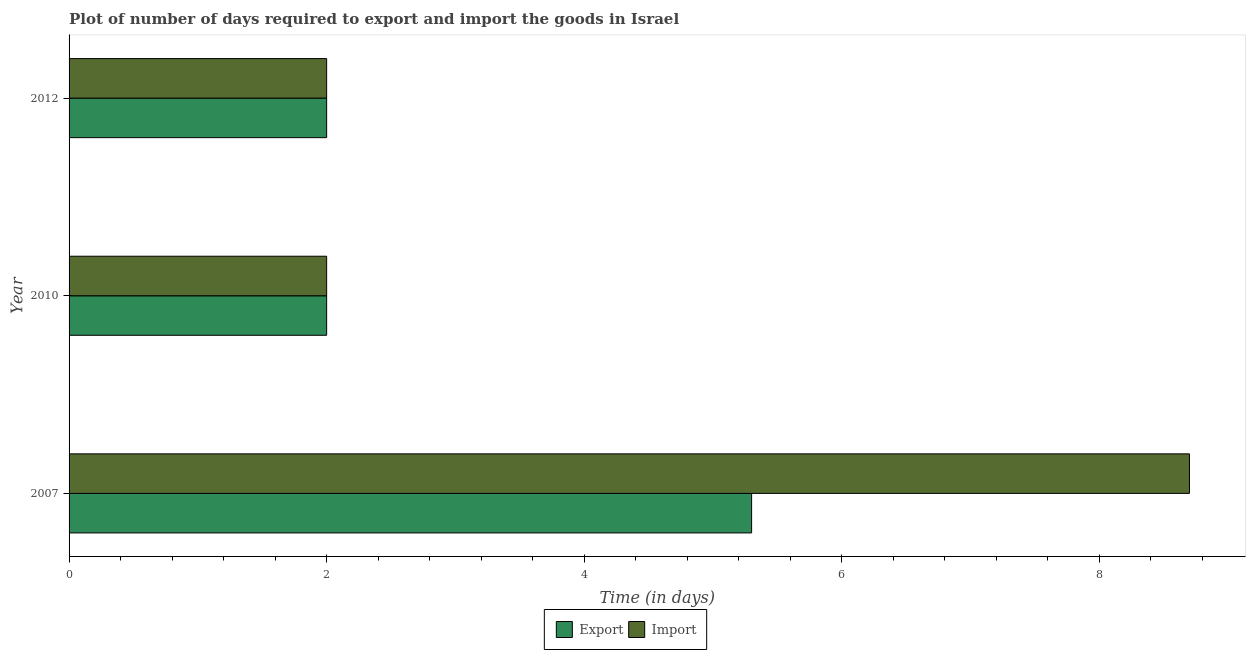How many groups of bars are there?
Ensure brevity in your answer.  3. Are the number of bars on each tick of the Y-axis equal?
Keep it short and to the point. Yes. How many bars are there on the 3rd tick from the bottom?
Keep it short and to the point. 2. What is the label of the 1st group of bars from the top?
Your response must be concise. 2012. What is the time required to import in 2007?
Keep it short and to the point. 8.7. Across all years, what is the maximum time required to import?
Make the answer very short. 8.7. In which year was the time required to import maximum?
Your response must be concise. 2007. In which year was the time required to export minimum?
Make the answer very short. 2010. What is the average time required to export per year?
Your answer should be compact. 3.1. In the year 2012, what is the difference between the time required to export and time required to import?
Your response must be concise. 0. In how many years, is the time required to export greater than 1.2000000000000002 days?
Your answer should be very brief. 3. Is the time required to export in 2007 less than that in 2012?
Offer a terse response. No. Is the difference between the time required to export in 2007 and 2010 greater than the difference between the time required to import in 2007 and 2010?
Your answer should be very brief. No. What is the difference between the highest and the second highest time required to import?
Offer a very short reply. 6.7. What does the 1st bar from the top in 2010 represents?
Your answer should be compact. Import. What does the 2nd bar from the bottom in 2012 represents?
Give a very brief answer. Import. How many years are there in the graph?
Your response must be concise. 3. What is the difference between two consecutive major ticks on the X-axis?
Your response must be concise. 2. Does the graph contain any zero values?
Keep it short and to the point. No. Does the graph contain grids?
Provide a short and direct response. No. Where does the legend appear in the graph?
Offer a terse response. Bottom center. How are the legend labels stacked?
Offer a very short reply. Horizontal. What is the title of the graph?
Keep it short and to the point. Plot of number of days required to export and import the goods in Israel. Does "Male labor force" appear as one of the legend labels in the graph?
Ensure brevity in your answer.  No. What is the label or title of the X-axis?
Your response must be concise. Time (in days). What is the label or title of the Y-axis?
Offer a very short reply. Year. What is the Time (in days) in Export in 2010?
Your response must be concise. 2. What is the Time (in days) of Import in 2010?
Offer a very short reply. 2. What is the Time (in days) of Export in 2012?
Offer a terse response. 2. Across all years, what is the maximum Time (in days) in Import?
Your answer should be very brief. 8.7. Across all years, what is the minimum Time (in days) in Import?
Your response must be concise. 2. What is the total Time (in days) in Export in the graph?
Your answer should be compact. 9.3. What is the total Time (in days) in Import in the graph?
Keep it short and to the point. 12.7. What is the difference between the Time (in days) in Export in 2007 and that in 2010?
Keep it short and to the point. 3.3. What is the difference between the Time (in days) in Import in 2007 and that in 2010?
Your response must be concise. 6.7. What is the difference between the Time (in days) of Export in 2007 and that in 2012?
Your response must be concise. 3.3. What is the difference between the Time (in days) of Import in 2010 and that in 2012?
Offer a very short reply. 0. What is the difference between the Time (in days) of Export in 2007 and the Time (in days) of Import in 2012?
Give a very brief answer. 3.3. What is the difference between the Time (in days) in Export in 2010 and the Time (in days) in Import in 2012?
Keep it short and to the point. 0. What is the average Time (in days) in Import per year?
Offer a terse response. 4.23. In the year 2007, what is the difference between the Time (in days) in Export and Time (in days) in Import?
Offer a very short reply. -3.4. In the year 2010, what is the difference between the Time (in days) in Export and Time (in days) in Import?
Offer a terse response. 0. In the year 2012, what is the difference between the Time (in days) in Export and Time (in days) in Import?
Provide a succinct answer. 0. What is the ratio of the Time (in days) in Export in 2007 to that in 2010?
Make the answer very short. 2.65. What is the ratio of the Time (in days) in Import in 2007 to that in 2010?
Make the answer very short. 4.35. What is the ratio of the Time (in days) in Export in 2007 to that in 2012?
Your answer should be very brief. 2.65. What is the ratio of the Time (in days) of Import in 2007 to that in 2012?
Ensure brevity in your answer.  4.35. What is the ratio of the Time (in days) in Export in 2010 to that in 2012?
Your response must be concise. 1. What is the difference between the highest and the second highest Time (in days) in Export?
Your answer should be compact. 3.3. What is the difference between the highest and the second highest Time (in days) in Import?
Your answer should be very brief. 6.7. 